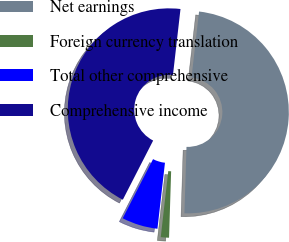Convert chart. <chart><loc_0><loc_0><loc_500><loc_500><pie_chart><fcel>Net earnings<fcel>Foreign currency translation<fcel>Total other comprehensive<fcel>Comprehensive income<nl><fcel>48.69%<fcel>1.31%<fcel>5.73%<fcel>44.27%<nl></chart> 